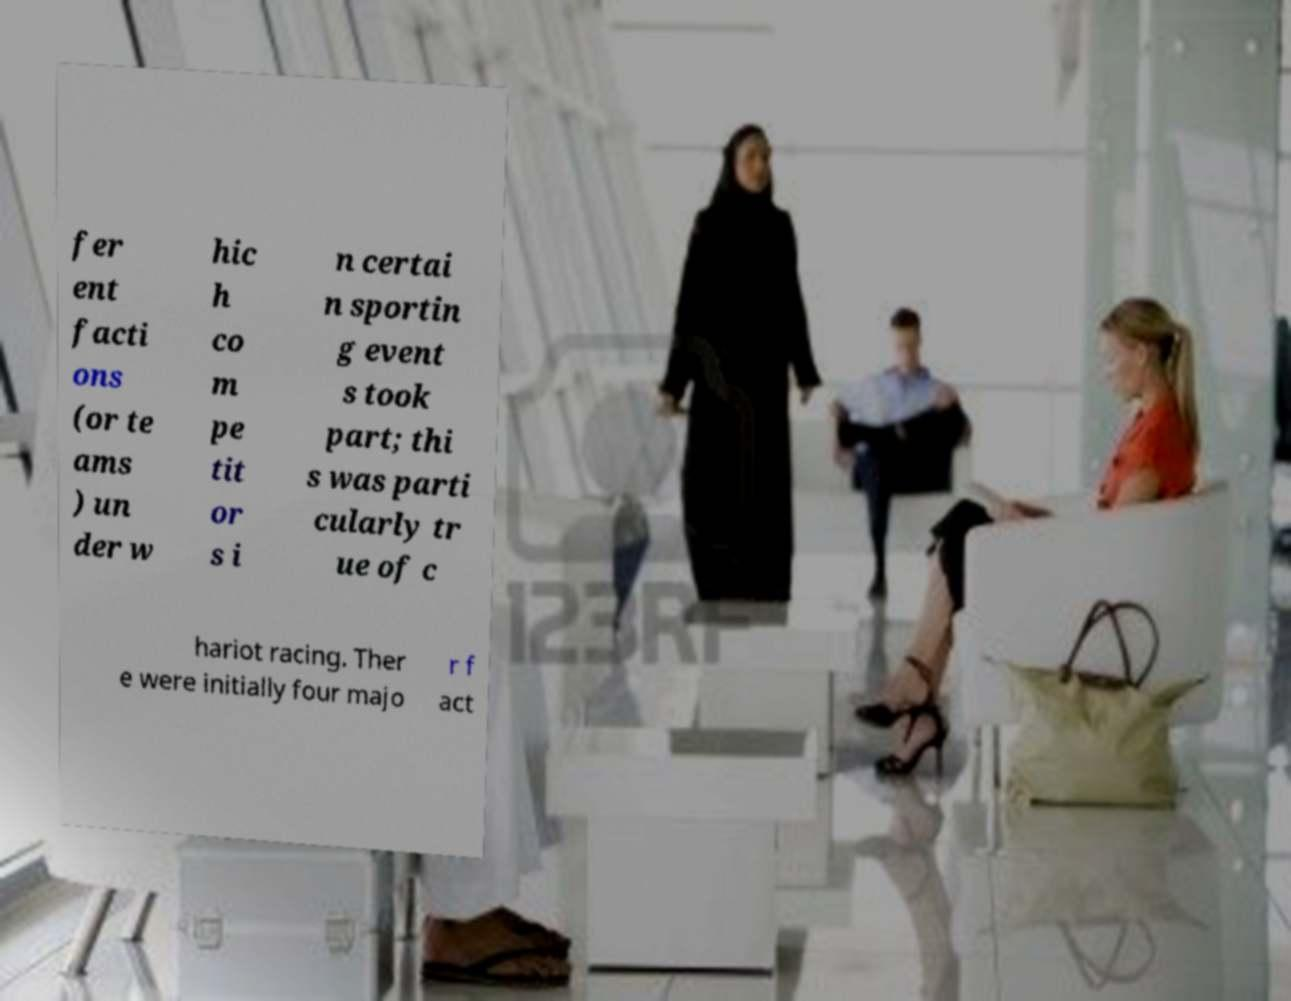Please read and relay the text visible in this image. What does it say? fer ent facti ons (or te ams ) un der w hic h co m pe tit or s i n certai n sportin g event s took part; thi s was parti cularly tr ue of c hariot racing. Ther e were initially four majo r f act 